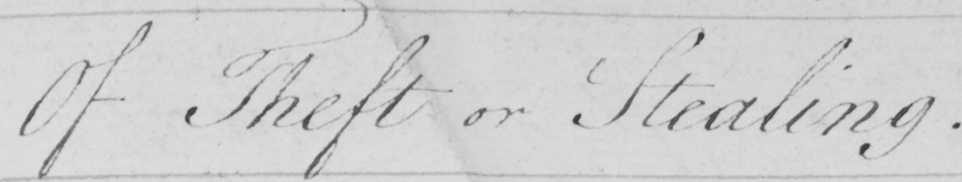Please provide the text content of this handwritten line. Of Theft or Stealing 